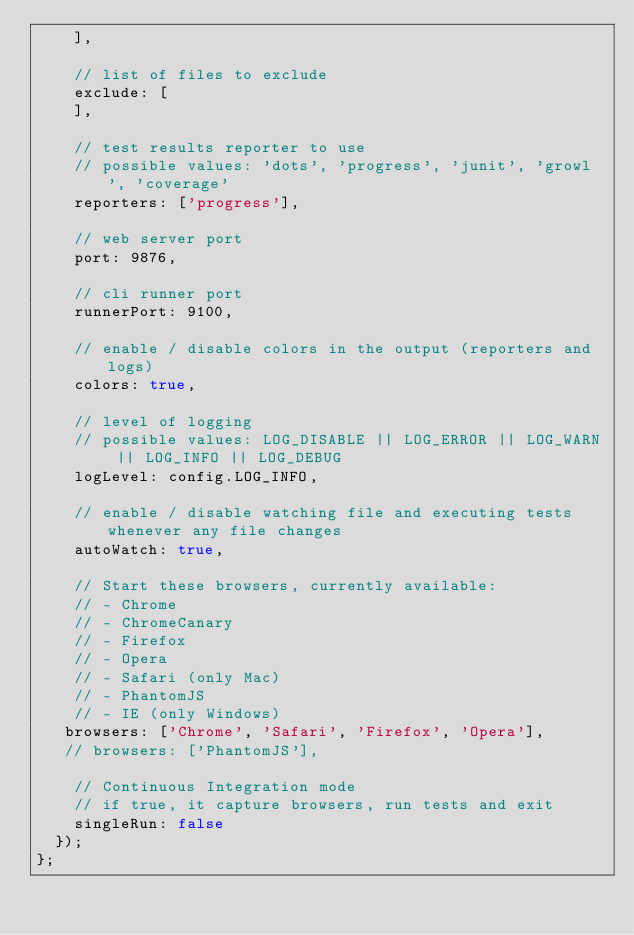<code> <loc_0><loc_0><loc_500><loc_500><_JavaScript_>    ],

    // list of files to exclude
    exclude: [
    ],

    // test results reporter to use
    // possible values: 'dots', 'progress', 'junit', 'growl', 'coverage'
    reporters: ['progress'],

    // web server port
    port: 9876,

    // cli runner port
    runnerPort: 9100,

    // enable / disable colors in the output (reporters and logs)
    colors: true,

    // level of logging
    // possible values: LOG_DISABLE || LOG_ERROR || LOG_WARN || LOG_INFO || LOG_DEBUG
    logLevel: config.LOG_INFO,

    // enable / disable watching file and executing tests whenever any file changes
    autoWatch: true,

    // Start these browsers, currently available:
    // - Chrome
    // - ChromeCanary
    // - Firefox
    // - Opera
    // - Safari (only Mac)
    // - PhantomJS
    // - IE (only Windows)
   browsers: ['Chrome', 'Safari', 'Firefox', 'Opera'],
   // browsers: ['PhantomJS'],

    // Continuous Integration mode
    // if true, it capture browsers, run tests and exit
    singleRun: false
  });
};
</code> 